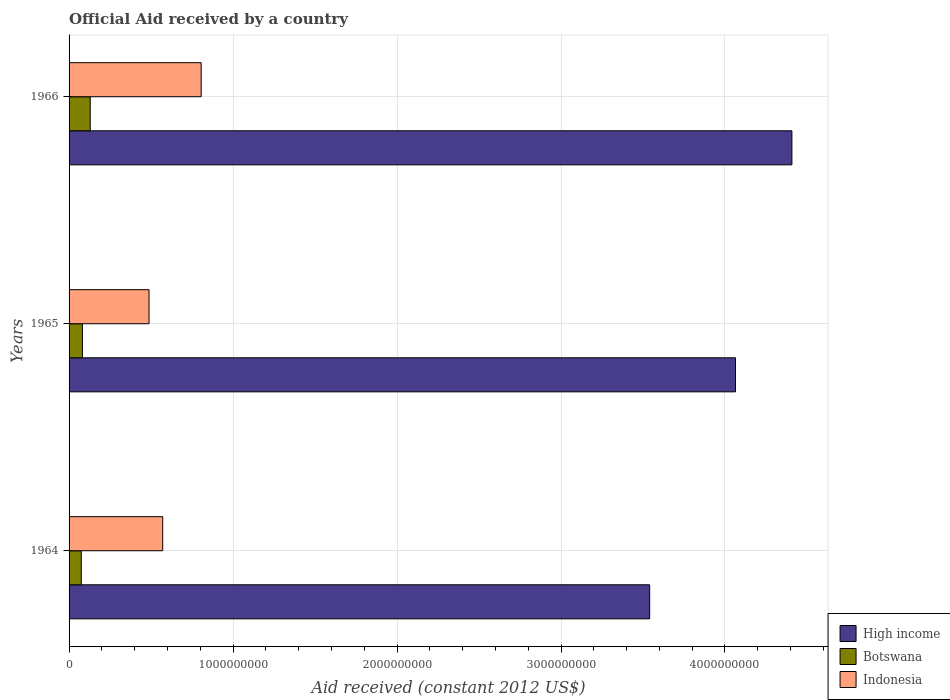Are the number of bars on each tick of the Y-axis equal?
Your answer should be compact. Yes. How many bars are there on the 3rd tick from the bottom?
Your response must be concise. 3. What is the label of the 3rd group of bars from the top?
Offer a terse response. 1964. What is the net official aid received in Indonesia in 1965?
Offer a terse response. 4.88e+08. Across all years, what is the maximum net official aid received in High income?
Your answer should be compact. 4.41e+09. Across all years, what is the minimum net official aid received in Indonesia?
Your answer should be very brief. 4.88e+08. In which year was the net official aid received in Indonesia maximum?
Ensure brevity in your answer.  1966. In which year was the net official aid received in High income minimum?
Make the answer very short. 1964. What is the total net official aid received in Indonesia in the graph?
Your response must be concise. 1.86e+09. What is the difference between the net official aid received in Indonesia in 1964 and that in 1965?
Provide a short and direct response. 8.34e+07. What is the difference between the net official aid received in Botswana in 1964 and the net official aid received in Indonesia in 1966?
Your response must be concise. -7.31e+08. What is the average net official aid received in High income per year?
Offer a terse response. 4.00e+09. In the year 1966, what is the difference between the net official aid received in Indonesia and net official aid received in Botswana?
Your answer should be compact. 6.77e+08. In how many years, is the net official aid received in High income greater than 4000000000 US$?
Provide a succinct answer. 2. What is the ratio of the net official aid received in Indonesia in 1964 to that in 1965?
Provide a succinct answer. 1.17. Is the difference between the net official aid received in Indonesia in 1965 and 1966 greater than the difference between the net official aid received in Botswana in 1965 and 1966?
Make the answer very short. No. What is the difference between the highest and the second highest net official aid received in Botswana?
Your answer should be compact. 4.77e+07. What is the difference between the highest and the lowest net official aid received in High income?
Offer a terse response. 8.68e+08. In how many years, is the net official aid received in Indonesia greater than the average net official aid received in Indonesia taken over all years?
Ensure brevity in your answer.  1. Is the sum of the net official aid received in Botswana in 1964 and 1965 greater than the maximum net official aid received in Indonesia across all years?
Ensure brevity in your answer.  No. What does the 2nd bar from the bottom in 1965 represents?
Provide a succinct answer. Botswana. Are all the bars in the graph horizontal?
Your answer should be very brief. Yes. Are the values on the major ticks of X-axis written in scientific E-notation?
Ensure brevity in your answer.  No. Does the graph contain any zero values?
Keep it short and to the point. No. Where does the legend appear in the graph?
Provide a succinct answer. Bottom right. How are the legend labels stacked?
Your answer should be compact. Vertical. What is the title of the graph?
Ensure brevity in your answer.  Official Aid received by a country. Does "Uruguay" appear as one of the legend labels in the graph?
Your answer should be compact. No. What is the label or title of the X-axis?
Give a very brief answer. Aid received (constant 2012 US$). What is the Aid received (constant 2012 US$) of High income in 1964?
Offer a terse response. 3.54e+09. What is the Aid received (constant 2012 US$) of Botswana in 1964?
Make the answer very short. 7.46e+07. What is the Aid received (constant 2012 US$) in Indonesia in 1964?
Make the answer very short. 5.71e+08. What is the Aid received (constant 2012 US$) in High income in 1965?
Your answer should be very brief. 4.06e+09. What is the Aid received (constant 2012 US$) of Botswana in 1965?
Keep it short and to the point. 8.14e+07. What is the Aid received (constant 2012 US$) of Indonesia in 1965?
Provide a succinct answer. 4.88e+08. What is the Aid received (constant 2012 US$) in High income in 1966?
Ensure brevity in your answer.  4.41e+09. What is the Aid received (constant 2012 US$) of Botswana in 1966?
Provide a short and direct response. 1.29e+08. What is the Aid received (constant 2012 US$) in Indonesia in 1966?
Keep it short and to the point. 8.06e+08. Across all years, what is the maximum Aid received (constant 2012 US$) in High income?
Your response must be concise. 4.41e+09. Across all years, what is the maximum Aid received (constant 2012 US$) in Botswana?
Offer a very short reply. 1.29e+08. Across all years, what is the maximum Aid received (constant 2012 US$) in Indonesia?
Your response must be concise. 8.06e+08. Across all years, what is the minimum Aid received (constant 2012 US$) of High income?
Your answer should be very brief. 3.54e+09. Across all years, what is the minimum Aid received (constant 2012 US$) of Botswana?
Your response must be concise. 7.46e+07. Across all years, what is the minimum Aid received (constant 2012 US$) in Indonesia?
Your response must be concise. 4.88e+08. What is the total Aid received (constant 2012 US$) in High income in the graph?
Offer a very short reply. 1.20e+1. What is the total Aid received (constant 2012 US$) in Botswana in the graph?
Make the answer very short. 2.85e+08. What is the total Aid received (constant 2012 US$) of Indonesia in the graph?
Your answer should be very brief. 1.86e+09. What is the difference between the Aid received (constant 2012 US$) of High income in 1964 and that in 1965?
Give a very brief answer. -5.23e+08. What is the difference between the Aid received (constant 2012 US$) in Botswana in 1964 and that in 1965?
Ensure brevity in your answer.  -6.76e+06. What is the difference between the Aid received (constant 2012 US$) in Indonesia in 1964 and that in 1965?
Offer a very short reply. 8.34e+07. What is the difference between the Aid received (constant 2012 US$) of High income in 1964 and that in 1966?
Your answer should be compact. -8.68e+08. What is the difference between the Aid received (constant 2012 US$) in Botswana in 1964 and that in 1966?
Your response must be concise. -5.45e+07. What is the difference between the Aid received (constant 2012 US$) of Indonesia in 1964 and that in 1966?
Ensure brevity in your answer.  -2.35e+08. What is the difference between the Aid received (constant 2012 US$) of High income in 1965 and that in 1966?
Your answer should be compact. -3.44e+08. What is the difference between the Aid received (constant 2012 US$) of Botswana in 1965 and that in 1966?
Provide a short and direct response. -4.77e+07. What is the difference between the Aid received (constant 2012 US$) of Indonesia in 1965 and that in 1966?
Offer a very short reply. -3.18e+08. What is the difference between the Aid received (constant 2012 US$) in High income in 1964 and the Aid received (constant 2012 US$) in Botswana in 1965?
Make the answer very short. 3.46e+09. What is the difference between the Aid received (constant 2012 US$) in High income in 1964 and the Aid received (constant 2012 US$) in Indonesia in 1965?
Offer a terse response. 3.05e+09. What is the difference between the Aid received (constant 2012 US$) in Botswana in 1964 and the Aid received (constant 2012 US$) in Indonesia in 1965?
Keep it short and to the point. -4.13e+08. What is the difference between the Aid received (constant 2012 US$) in High income in 1964 and the Aid received (constant 2012 US$) in Botswana in 1966?
Your response must be concise. 3.41e+09. What is the difference between the Aid received (constant 2012 US$) of High income in 1964 and the Aid received (constant 2012 US$) of Indonesia in 1966?
Offer a very short reply. 2.74e+09. What is the difference between the Aid received (constant 2012 US$) of Botswana in 1964 and the Aid received (constant 2012 US$) of Indonesia in 1966?
Your response must be concise. -7.31e+08. What is the difference between the Aid received (constant 2012 US$) of High income in 1965 and the Aid received (constant 2012 US$) of Botswana in 1966?
Make the answer very short. 3.94e+09. What is the difference between the Aid received (constant 2012 US$) in High income in 1965 and the Aid received (constant 2012 US$) in Indonesia in 1966?
Give a very brief answer. 3.26e+09. What is the difference between the Aid received (constant 2012 US$) in Botswana in 1965 and the Aid received (constant 2012 US$) in Indonesia in 1966?
Ensure brevity in your answer.  -7.24e+08. What is the average Aid received (constant 2012 US$) of High income per year?
Your answer should be compact. 4.00e+09. What is the average Aid received (constant 2012 US$) of Botswana per year?
Keep it short and to the point. 9.50e+07. What is the average Aid received (constant 2012 US$) in Indonesia per year?
Offer a terse response. 6.21e+08. In the year 1964, what is the difference between the Aid received (constant 2012 US$) of High income and Aid received (constant 2012 US$) of Botswana?
Your answer should be very brief. 3.47e+09. In the year 1964, what is the difference between the Aid received (constant 2012 US$) in High income and Aid received (constant 2012 US$) in Indonesia?
Offer a terse response. 2.97e+09. In the year 1964, what is the difference between the Aid received (constant 2012 US$) in Botswana and Aid received (constant 2012 US$) in Indonesia?
Your answer should be compact. -4.96e+08. In the year 1965, what is the difference between the Aid received (constant 2012 US$) in High income and Aid received (constant 2012 US$) in Botswana?
Your answer should be compact. 3.98e+09. In the year 1965, what is the difference between the Aid received (constant 2012 US$) in High income and Aid received (constant 2012 US$) in Indonesia?
Make the answer very short. 3.58e+09. In the year 1965, what is the difference between the Aid received (constant 2012 US$) of Botswana and Aid received (constant 2012 US$) of Indonesia?
Your response must be concise. -4.06e+08. In the year 1966, what is the difference between the Aid received (constant 2012 US$) of High income and Aid received (constant 2012 US$) of Botswana?
Offer a very short reply. 4.28e+09. In the year 1966, what is the difference between the Aid received (constant 2012 US$) in High income and Aid received (constant 2012 US$) in Indonesia?
Keep it short and to the point. 3.60e+09. In the year 1966, what is the difference between the Aid received (constant 2012 US$) in Botswana and Aid received (constant 2012 US$) in Indonesia?
Provide a succinct answer. -6.77e+08. What is the ratio of the Aid received (constant 2012 US$) of High income in 1964 to that in 1965?
Offer a very short reply. 0.87. What is the ratio of the Aid received (constant 2012 US$) in Botswana in 1964 to that in 1965?
Offer a terse response. 0.92. What is the ratio of the Aid received (constant 2012 US$) of Indonesia in 1964 to that in 1965?
Your response must be concise. 1.17. What is the ratio of the Aid received (constant 2012 US$) in High income in 1964 to that in 1966?
Offer a terse response. 0.8. What is the ratio of the Aid received (constant 2012 US$) in Botswana in 1964 to that in 1966?
Ensure brevity in your answer.  0.58. What is the ratio of the Aid received (constant 2012 US$) of Indonesia in 1964 to that in 1966?
Offer a terse response. 0.71. What is the ratio of the Aid received (constant 2012 US$) in High income in 1965 to that in 1966?
Give a very brief answer. 0.92. What is the ratio of the Aid received (constant 2012 US$) of Botswana in 1965 to that in 1966?
Provide a succinct answer. 0.63. What is the ratio of the Aid received (constant 2012 US$) in Indonesia in 1965 to that in 1966?
Make the answer very short. 0.61. What is the difference between the highest and the second highest Aid received (constant 2012 US$) of High income?
Offer a very short reply. 3.44e+08. What is the difference between the highest and the second highest Aid received (constant 2012 US$) of Botswana?
Offer a very short reply. 4.77e+07. What is the difference between the highest and the second highest Aid received (constant 2012 US$) in Indonesia?
Give a very brief answer. 2.35e+08. What is the difference between the highest and the lowest Aid received (constant 2012 US$) of High income?
Provide a short and direct response. 8.68e+08. What is the difference between the highest and the lowest Aid received (constant 2012 US$) of Botswana?
Offer a terse response. 5.45e+07. What is the difference between the highest and the lowest Aid received (constant 2012 US$) in Indonesia?
Your response must be concise. 3.18e+08. 